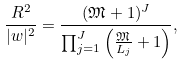<formula> <loc_0><loc_0><loc_500><loc_500>\frac { R ^ { 2 } } { | w | ^ { 2 } } = \frac { ( \mathfrak { M } + 1 ) ^ { J } } { \prod _ { j = 1 } ^ { J } \left ( \frac { \mathfrak { M } } { L _ { j } } + 1 \right ) } ,</formula> 